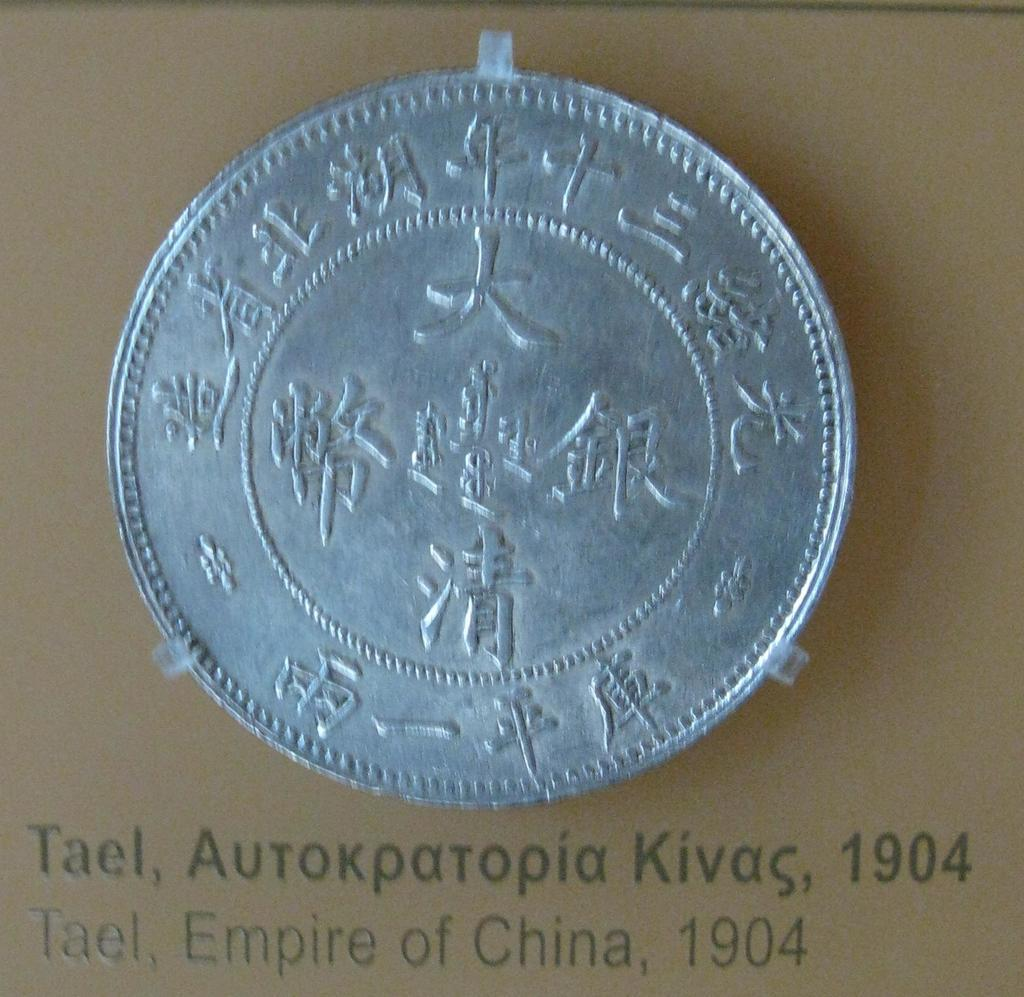<image>
Present a compact description of the photo's key features. Tael, Empire of China, 1904 is captioned below this coin. 